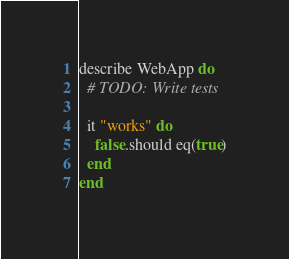<code> <loc_0><loc_0><loc_500><loc_500><_Crystal_>describe WebApp do
  # TODO: Write tests

  it "works" do
    false.should eq(true)
  end
end
</code> 